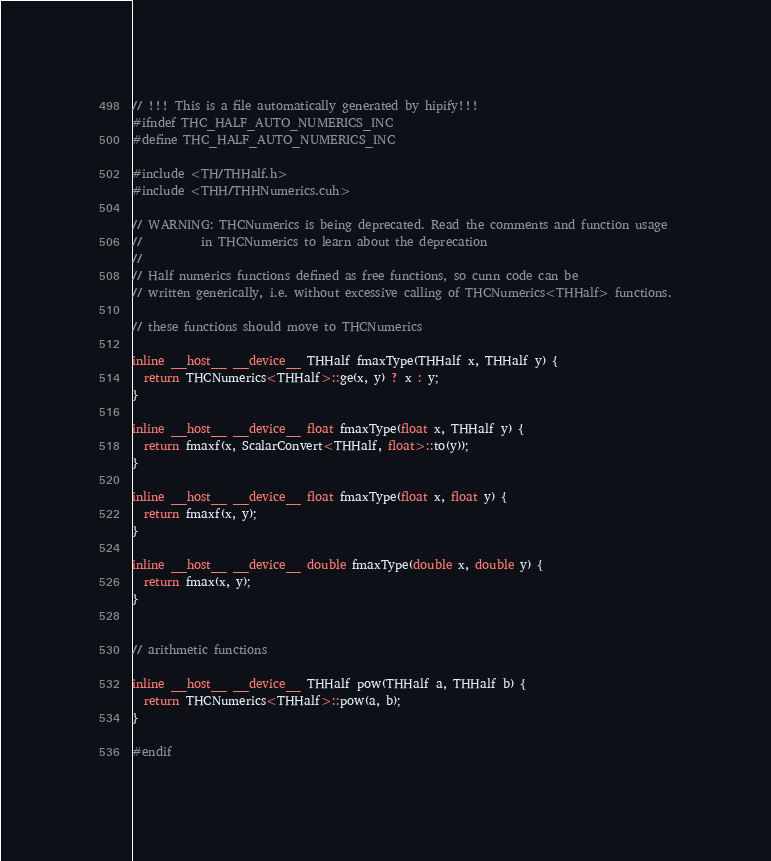Convert code to text. <code><loc_0><loc_0><loc_500><loc_500><_Cuda_>// !!! This is a file automatically generated by hipify!!!
#ifndef THC_HALF_AUTO_NUMERICS_INC
#define THC_HALF_AUTO_NUMERICS_INC

#include <TH/THHalf.h>
#include <THH/THHNumerics.cuh>

// WARNING: THCNumerics is being deprecated. Read the comments and function usage
//          in THCNumerics to learn about the deprecation
//
// Half numerics functions defined as free functions, so cunn code can be
// written generically, i.e. without excessive calling of THCNumerics<THHalf> functions.

// these functions should move to THCNumerics

inline __host__ __device__ THHalf fmaxType(THHalf x, THHalf y) {
  return THCNumerics<THHalf>::ge(x, y) ? x : y;
}

inline __host__ __device__ float fmaxType(float x, THHalf y) {
  return fmaxf(x, ScalarConvert<THHalf, float>::to(y));
}

inline __host__ __device__ float fmaxType(float x, float y) {
  return fmaxf(x, y);
}

inline __host__ __device__ double fmaxType(double x, double y) {
  return fmax(x, y);
}


// arithmetic functions

inline __host__ __device__ THHalf pow(THHalf a, THHalf b) {
  return THCNumerics<THHalf>::pow(a, b);
}

#endif
</code> 